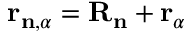Convert formula to latex. <formula><loc_0><loc_0><loc_500><loc_500>r _ { n , \alpha } = R _ { n } + r _ { \alpha }</formula> 